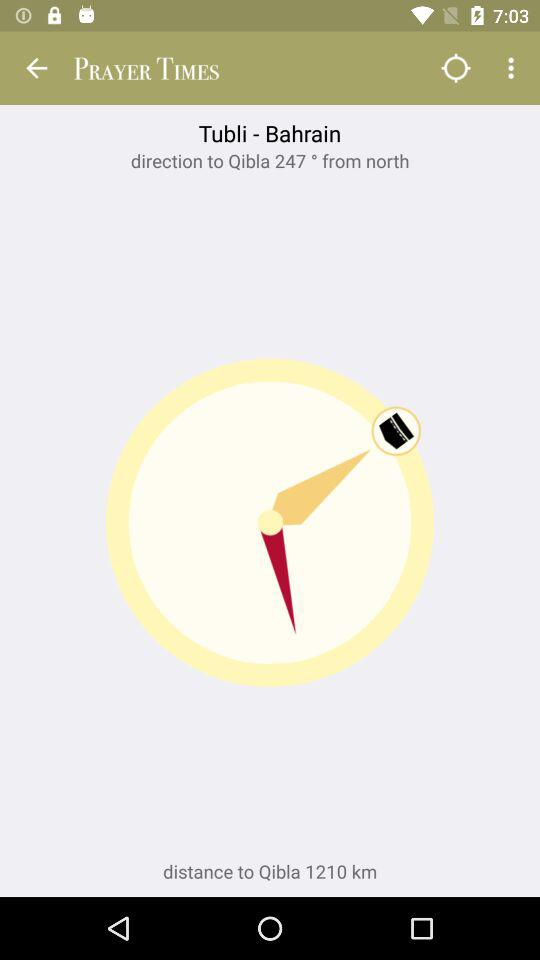How many degrees is the direction to Qibla from north?
Answer the question using a single word or phrase. 247 